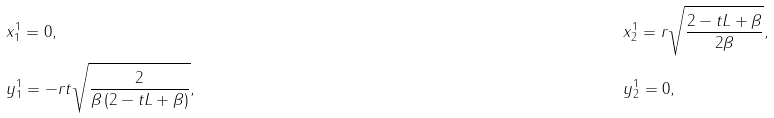Convert formula to latex. <formula><loc_0><loc_0><loc_500><loc_500>& x ^ { 1 } _ { 1 } = 0 , & & x _ { 2 } ^ { 1 } = r \sqrt { \frac { 2 - t L + \beta } { 2 \beta } } , \\ & y _ { 1 } ^ { 1 } = - r t \sqrt { \frac { 2 } { \beta \left ( 2 - t L + \beta \right ) } } , & & y ^ { 1 } _ { 2 } = 0 ,</formula> 